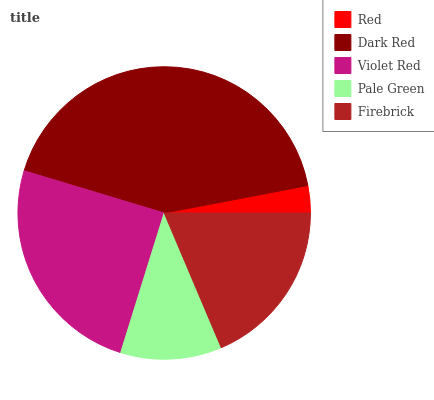Is Red the minimum?
Answer yes or no. Yes. Is Dark Red the maximum?
Answer yes or no. Yes. Is Violet Red the minimum?
Answer yes or no. No. Is Violet Red the maximum?
Answer yes or no. No. Is Dark Red greater than Violet Red?
Answer yes or no. Yes. Is Violet Red less than Dark Red?
Answer yes or no. Yes. Is Violet Red greater than Dark Red?
Answer yes or no. No. Is Dark Red less than Violet Red?
Answer yes or no. No. Is Firebrick the high median?
Answer yes or no. Yes. Is Firebrick the low median?
Answer yes or no. Yes. Is Red the high median?
Answer yes or no. No. Is Pale Green the low median?
Answer yes or no. No. 